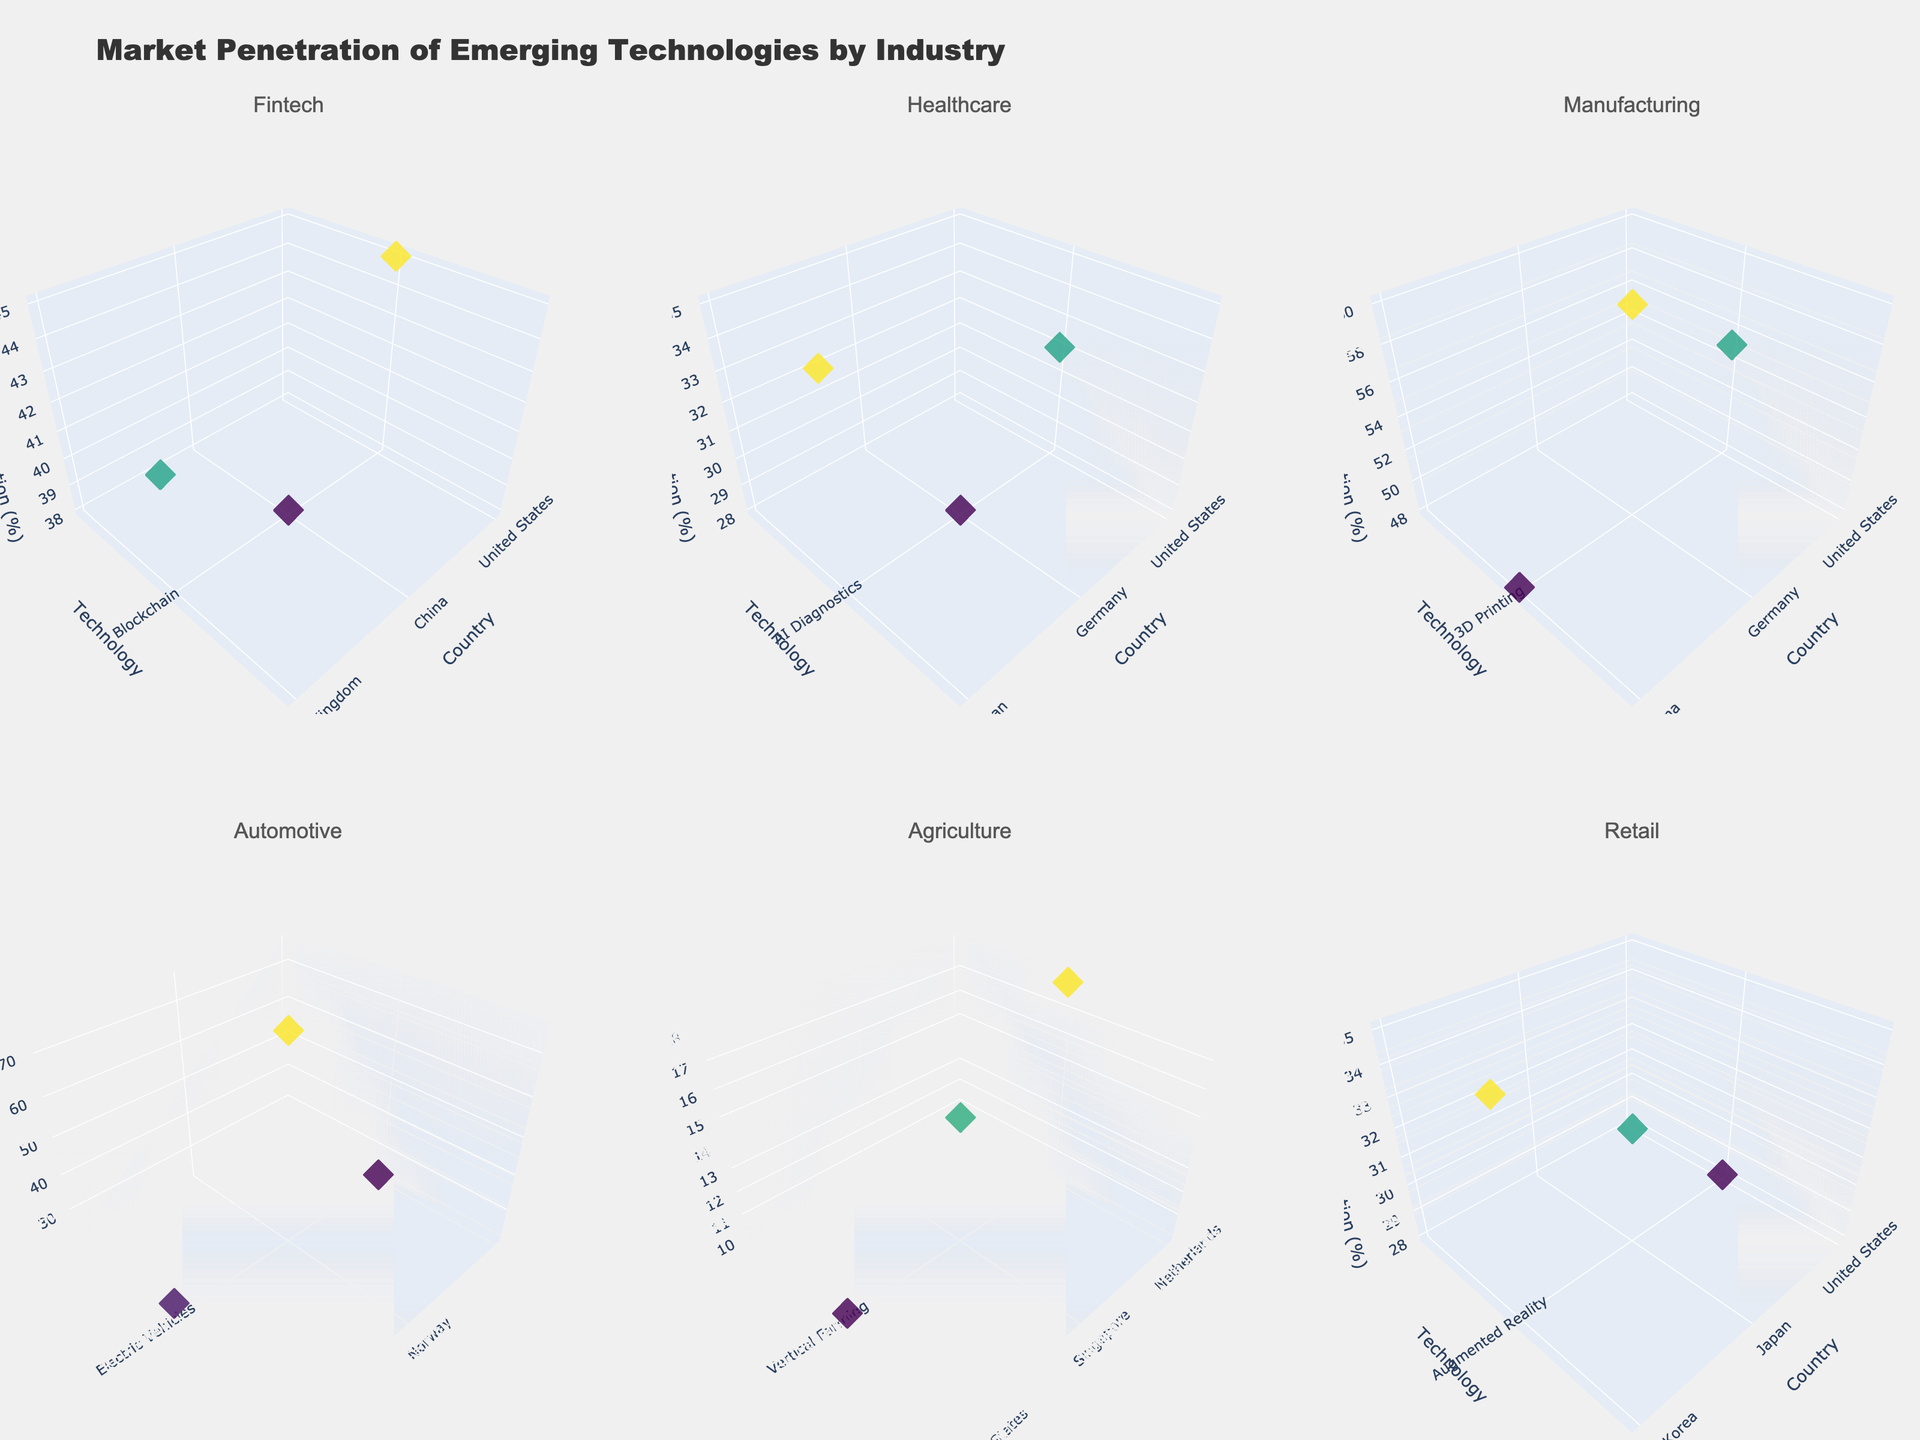what is the title of the figure? The title of the figure is prominently displayed at the top of the chart. The title is usually in a larger font size and bolded to make it easily noticeable.
Answer: Market Penetration of Emerging Technologies by Industry What axis title represents the x-axis in the subplot for Healthcare? The subplot for Healthcare has an x-axis labeled, and typically, the axis title is mentioned in smaller text along the axis line. For the given data, the x-axis represents geographical entities or countries.
Answer: Country In the Manufacturing subplot, which country has the highest market penetration for 3D Printing? In the Manufacturing subplot, observe the z-axis values for the data points representing different countries. The country with the highest z-value (Market Penetration) has the highest penetration.
Answer: Germany From the given figure, which industry has the highest market penetration overall for one of its technologies? Compare the maximum market penetration across all subplots. Look at the z-axis values for each subplot, and identify the highest value among all.
Answer: Automotive (Norway with Electric Vehicles at 75%) What is the average market penetration for AI Diagnostics across all countries? Calculate the mean value by summing the market penetration values for AI Diagnostics in the United States, Germany, and Japan and dividing by the number of countries. (32 + 28 + 35) / 3 = 31.67
Answer: 31.67 Which country has the lowest market penetration for Vertical Farming, and what is the value? In the Agriculture subplot focusing on Vertical Farming, identify the country with the lowest z-axis value to determine the lowest market penetration.
Answer: United States, 10% Compare the market penetration of Augmented Reality in the United States with that in South Korea. Which country has a higher penetration and by how much? Check the z-axis values for Augmented Reality in both the United States and South Korea. Subtract the lower value from the higher value to find the difference.
Answer: South Korea by 7% In the subplot representing Electric Vehicles, which country stands out and why? Identify the country with an outstanding value (either the highest or lowest) in the Electric Vehicles subplot. Look for any significant outliers compared to others on the z-axis.
Answer: Norway due to the very high penetration rate of 75% Determine the overall trend for the market penetration of Blockchain technology in Fintech across the United States, China, and the United Kingdom. Observe the z-axis values for Blockchain technology in the Fintech subplot across the three countries. Note if the values are increasing, decreasing, or inconsistent.
Answer: Inconsistent (45, 38, 42 respectively) Compare the market penetration of Blockchain in China to AI Diagnostics in Japan. Which one is higher? Examine the z-axis values for Blockchain in China and AI Diagnostics in Japan. Compare the two values directly.
Answer: AI Diagnostics in Japan 